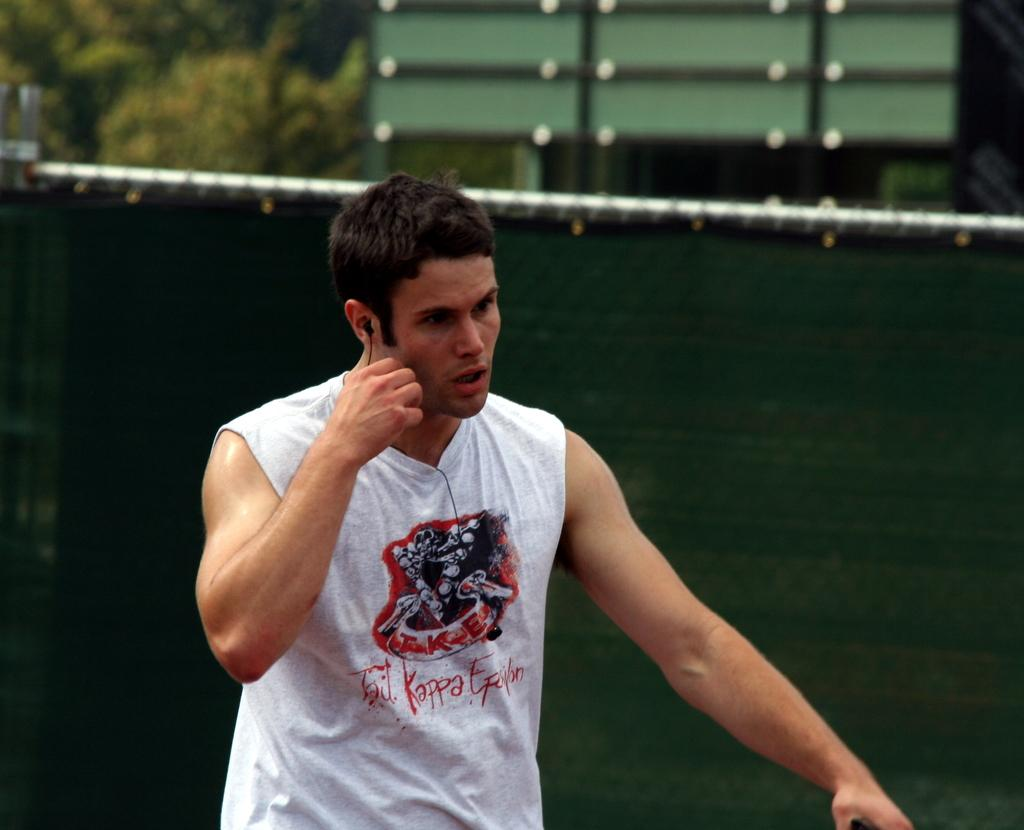<image>
Give a short and clear explanation of the subsequent image. A man wearing a shirt that says Tri Kappa Epillon walks in front of a green fence. 